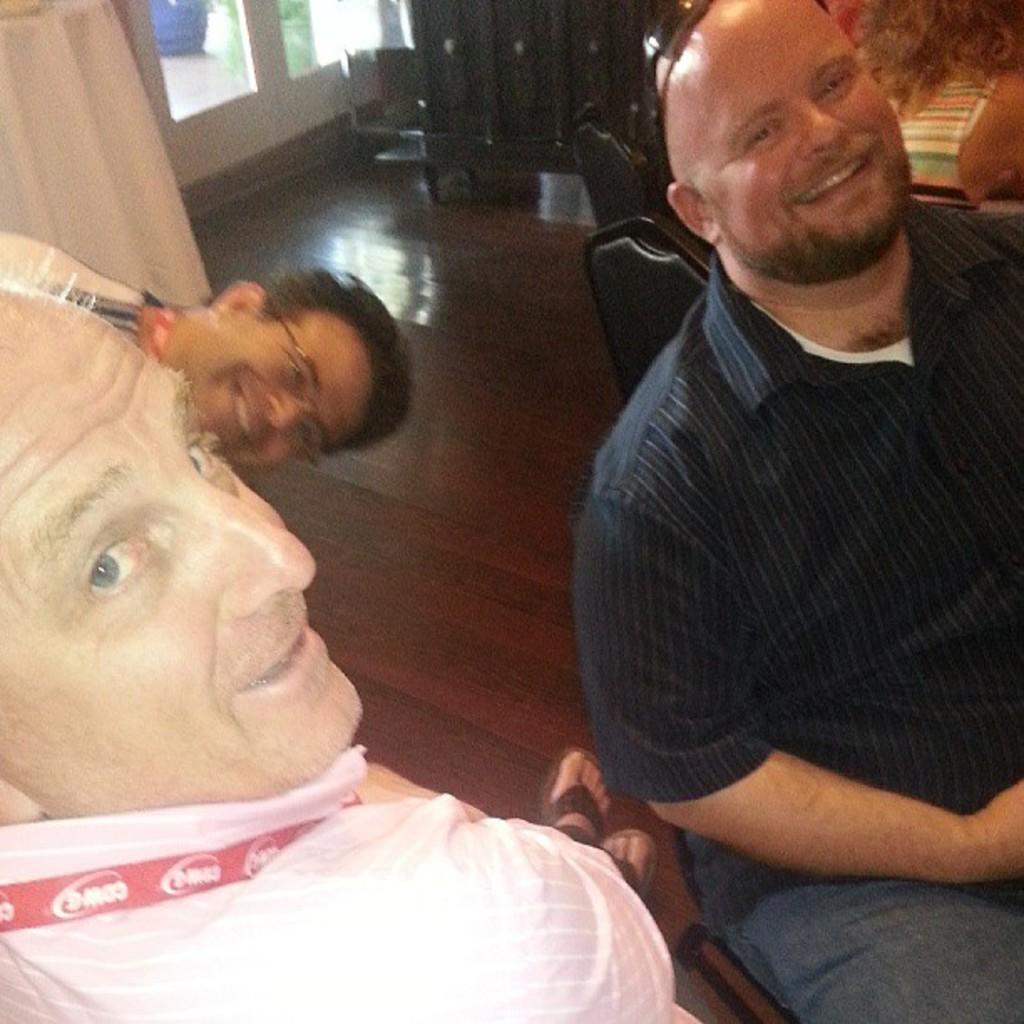What are the persons in the image doing? The persons in the image are sitting and smiling. What type of flooring is present in the image? There is wooden flooring in the image. What type of furniture can be seen in the image? There are wooden cupboards in the image. What can be seen in the background of the image? A class one dose is visible in the background of the image. What type of trail can be seen in the image? There is no trail present in the image. What causes the burst of laughter in the image? There is no burst of laughter depicted in the image; the persons are simply smiling. 